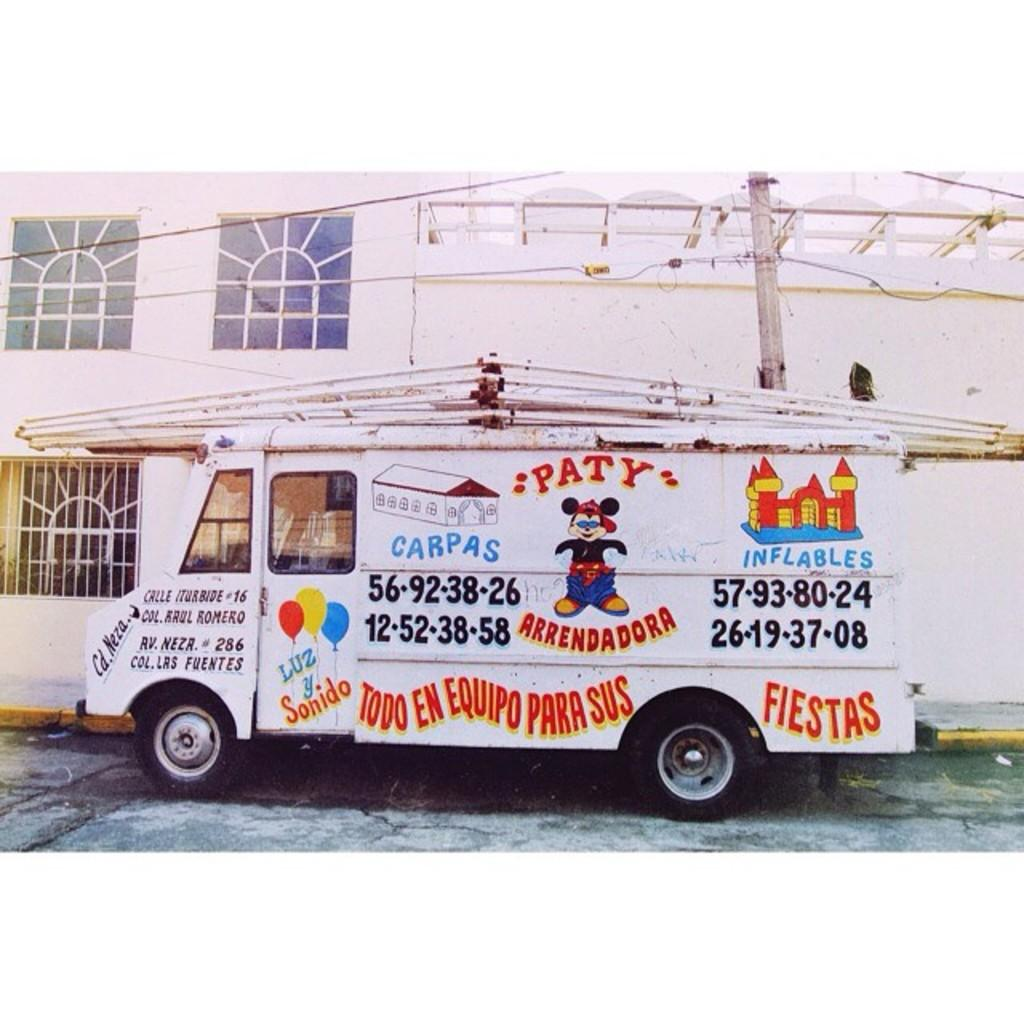<image>
Provide a brief description of the given image. A white truck labeled PATY ARRENDADORA parked on the side of the road 